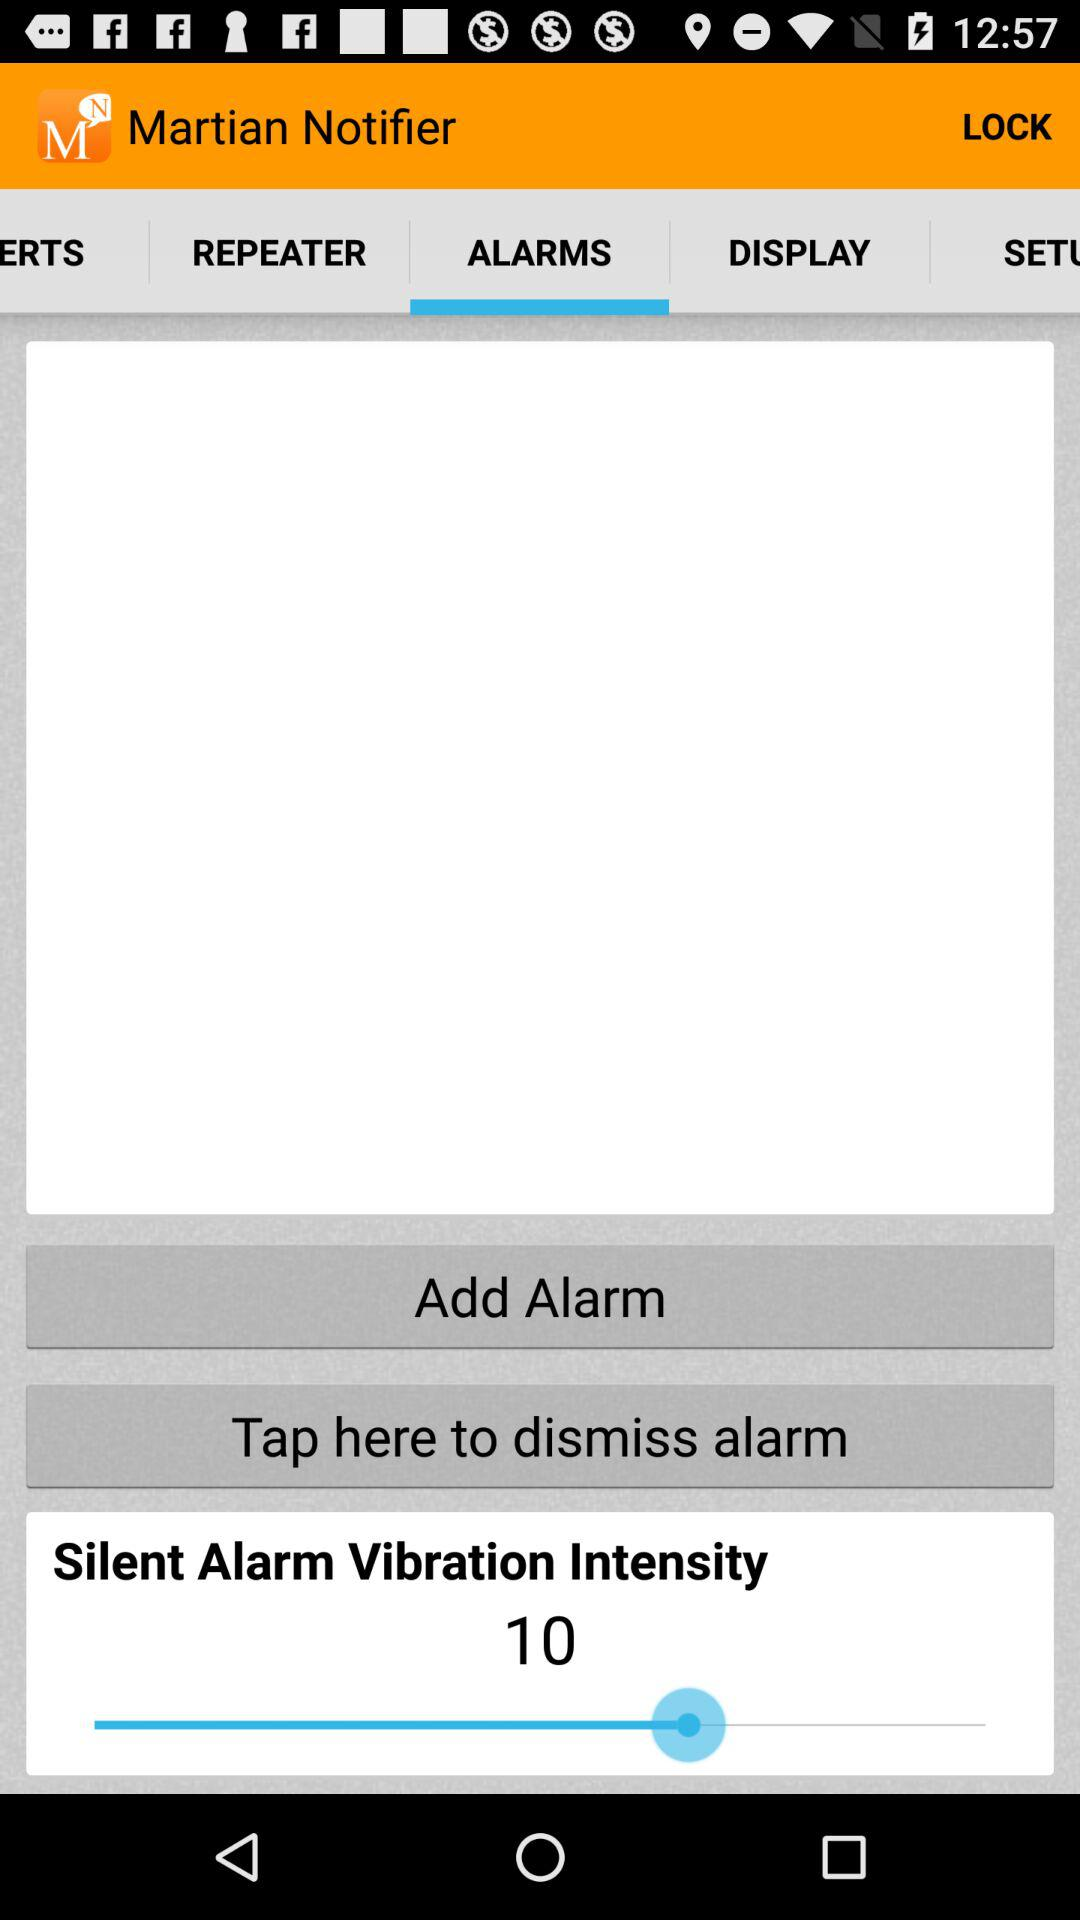Which tab is selected? The selected tab is "ALARMS". 